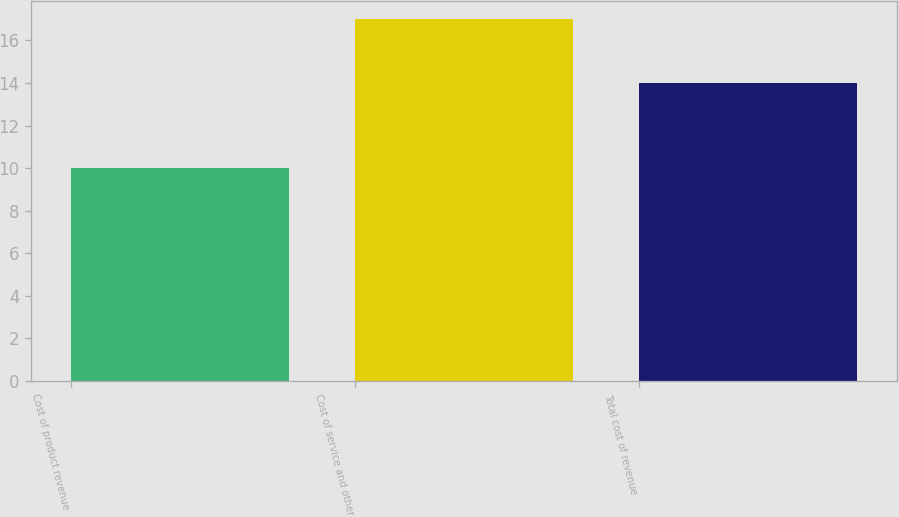Convert chart to OTSL. <chart><loc_0><loc_0><loc_500><loc_500><bar_chart><fcel>Cost of product revenue<fcel>Cost of service and other<fcel>Total cost of revenue<nl><fcel>10<fcel>17<fcel>14<nl></chart> 